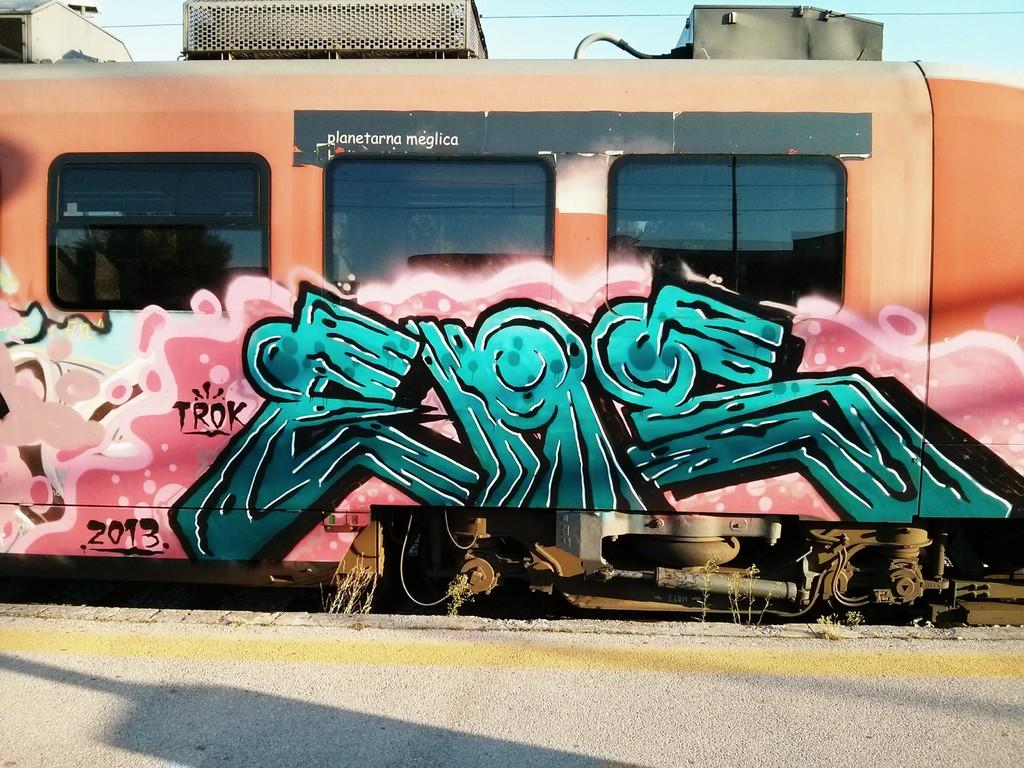What is the subject of the graffiti on the train? The facts provided do not give information about the content of the graffiti. What type of vehicle is the graffiti on? The graffiti is on a train. What feature of the train is mentioned in the image? There are glass windows in the image. How many baseball players are visible in the image? There are no baseball players present in the image; it features graffiti on a train and glass windows. 